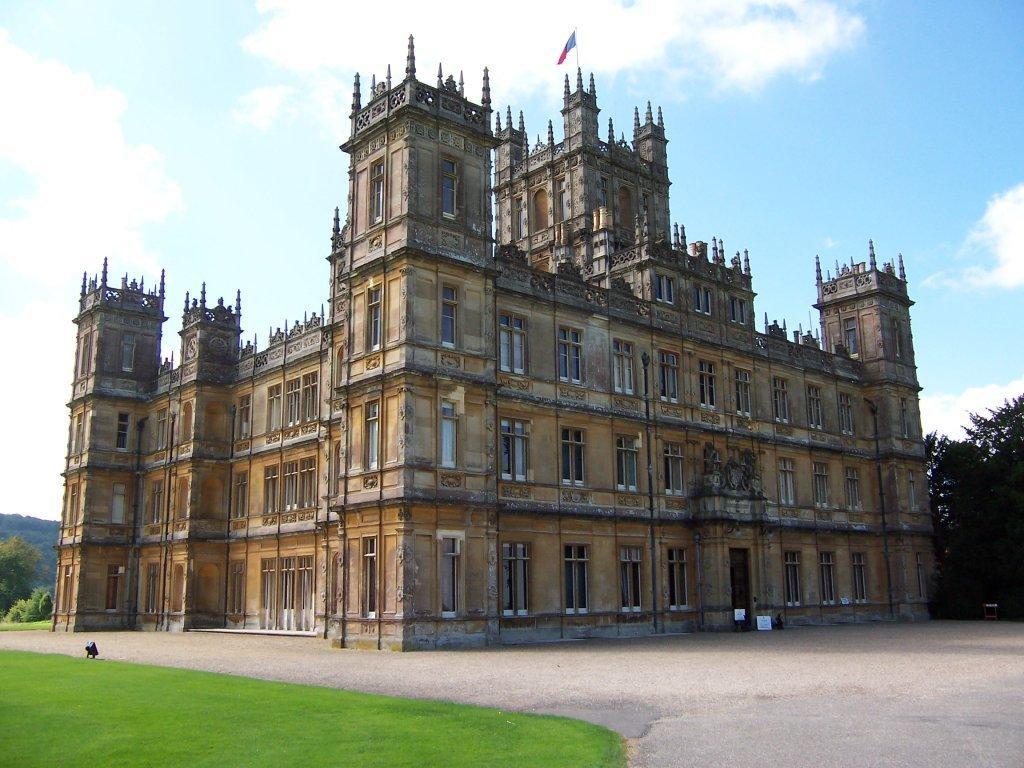In one or two sentences, can you explain what this image depicts? At the bottom of the picture, we see the grass and the road. In the middle of the picture, we see a castle. On top of the castle, we see a flag in red and blue color. On either side of the picture, there are trees. At the top, we see the sky and the clouds. 